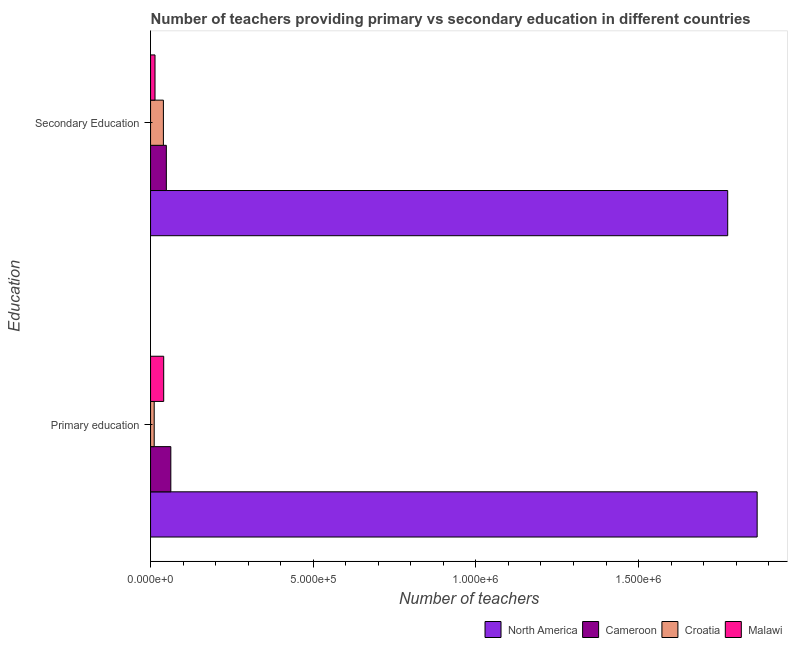How many different coloured bars are there?
Your answer should be compact. 4. How many groups of bars are there?
Keep it short and to the point. 2. How many bars are there on the 2nd tick from the bottom?
Offer a very short reply. 4. What is the label of the 2nd group of bars from the top?
Your response must be concise. Primary education. What is the number of primary teachers in Croatia?
Provide a succinct answer. 1.12e+04. Across all countries, what is the maximum number of primary teachers?
Offer a very short reply. 1.86e+06. Across all countries, what is the minimum number of secondary teachers?
Your response must be concise. 1.37e+04. In which country was the number of primary teachers maximum?
Give a very brief answer. North America. In which country was the number of secondary teachers minimum?
Your answer should be compact. Malawi. What is the total number of secondary teachers in the graph?
Your answer should be very brief. 1.88e+06. What is the difference between the number of primary teachers in North America and that in Malawi?
Offer a terse response. 1.82e+06. What is the difference between the number of primary teachers in Malawi and the number of secondary teachers in North America?
Give a very brief answer. -1.73e+06. What is the average number of primary teachers per country?
Your answer should be very brief. 4.95e+05. What is the difference between the number of secondary teachers and number of primary teachers in North America?
Your response must be concise. -9.06e+04. What is the ratio of the number of secondary teachers in North America to that in Cameroon?
Keep it short and to the point. 36.58. Is the number of primary teachers in North America less than that in Malawi?
Offer a terse response. No. What does the 1st bar from the top in Primary education represents?
Provide a succinct answer. Malawi. What does the 4th bar from the bottom in Secondary Education represents?
Offer a very short reply. Malawi. What is the difference between two consecutive major ticks on the X-axis?
Give a very brief answer. 5.00e+05. Are the values on the major ticks of X-axis written in scientific E-notation?
Your answer should be very brief. Yes. Does the graph contain any zero values?
Offer a very short reply. No. How are the legend labels stacked?
Your response must be concise. Horizontal. What is the title of the graph?
Make the answer very short. Number of teachers providing primary vs secondary education in different countries. What is the label or title of the X-axis?
Ensure brevity in your answer.  Number of teachers. What is the label or title of the Y-axis?
Offer a very short reply. Education. What is the Number of teachers of North America in Primary education?
Provide a succinct answer. 1.86e+06. What is the Number of teachers in Cameroon in Primary education?
Ensure brevity in your answer.  6.23e+04. What is the Number of teachers of Croatia in Primary education?
Make the answer very short. 1.12e+04. What is the Number of teachers of Malawi in Primary education?
Your response must be concise. 4.04e+04. What is the Number of teachers of North America in Secondary Education?
Keep it short and to the point. 1.77e+06. What is the Number of teachers in Cameroon in Secondary Education?
Your answer should be very brief. 4.85e+04. What is the Number of teachers of Croatia in Secondary Education?
Provide a succinct answer. 3.95e+04. What is the Number of teachers of Malawi in Secondary Education?
Ensure brevity in your answer.  1.37e+04. Across all Education, what is the maximum Number of teachers of North America?
Provide a short and direct response. 1.86e+06. Across all Education, what is the maximum Number of teachers in Cameroon?
Provide a short and direct response. 6.23e+04. Across all Education, what is the maximum Number of teachers of Croatia?
Give a very brief answer. 3.95e+04. Across all Education, what is the maximum Number of teachers in Malawi?
Keep it short and to the point. 4.04e+04. Across all Education, what is the minimum Number of teachers in North America?
Give a very brief answer. 1.77e+06. Across all Education, what is the minimum Number of teachers in Cameroon?
Provide a succinct answer. 4.85e+04. Across all Education, what is the minimum Number of teachers in Croatia?
Your answer should be compact. 1.12e+04. Across all Education, what is the minimum Number of teachers in Malawi?
Offer a terse response. 1.37e+04. What is the total Number of teachers of North America in the graph?
Make the answer very short. 3.64e+06. What is the total Number of teachers in Cameroon in the graph?
Your answer should be compact. 1.11e+05. What is the total Number of teachers in Croatia in the graph?
Offer a terse response. 5.07e+04. What is the total Number of teachers of Malawi in the graph?
Provide a short and direct response. 5.40e+04. What is the difference between the Number of teachers in North America in Primary education and that in Secondary Education?
Provide a succinct answer. 9.06e+04. What is the difference between the Number of teachers of Cameroon in Primary education and that in Secondary Education?
Make the answer very short. 1.38e+04. What is the difference between the Number of teachers of Croatia in Primary education and that in Secondary Education?
Your response must be concise. -2.83e+04. What is the difference between the Number of teachers in Malawi in Primary education and that in Secondary Education?
Your answer should be compact. 2.67e+04. What is the difference between the Number of teachers in North America in Primary education and the Number of teachers in Cameroon in Secondary Education?
Provide a short and direct response. 1.82e+06. What is the difference between the Number of teachers in North America in Primary education and the Number of teachers in Croatia in Secondary Education?
Keep it short and to the point. 1.83e+06. What is the difference between the Number of teachers of North America in Primary education and the Number of teachers of Malawi in Secondary Education?
Make the answer very short. 1.85e+06. What is the difference between the Number of teachers of Cameroon in Primary education and the Number of teachers of Croatia in Secondary Education?
Offer a very short reply. 2.28e+04. What is the difference between the Number of teachers of Cameroon in Primary education and the Number of teachers of Malawi in Secondary Education?
Your answer should be compact. 4.86e+04. What is the difference between the Number of teachers in Croatia in Primary education and the Number of teachers in Malawi in Secondary Education?
Your answer should be compact. -2461. What is the average Number of teachers in North America per Education?
Provide a short and direct response. 1.82e+06. What is the average Number of teachers in Cameroon per Education?
Offer a terse response. 5.54e+04. What is the average Number of teachers of Croatia per Education?
Make the answer very short. 2.53e+04. What is the average Number of teachers in Malawi per Education?
Keep it short and to the point. 2.70e+04. What is the difference between the Number of teachers in North America and Number of teachers in Cameroon in Primary education?
Offer a terse response. 1.80e+06. What is the difference between the Number of teachers in North America and Number of teachers in Croatia in Primary education?
Provide a succinct answer. 1.85e+06. What is the difference between the Number of teachers in North America and Number of teachers in Malawi in Primary education?
Your response must be concise. 1.82e+06. What is the difference between the Number of teachers of Cameroon and Number of teachers of Croatia in Primary education?
Keep it short and to the point. 5.11e+04. What is the difference between the Number of teachers in Cameroon and Number of teachers in Malawi in Primary education?
Keep it short and to the point. 2.19e+04. What is the difference between the Number of teachers in Croatia and Number of teachers in Malawi in Primary education?
Your answer should be very brief. -2.92e+04. What is the difference between the Number of teachers of North America and Number of teachers of Cameroon in Secondary Education?
Offer a very short reply. 1.73e+06. What is the difference between the Number of teachers of North America and Number of teachers of Croatia in Secondary Education?
Keep it short and to the point. 1.73e+06. What is the difference between the Number of teachers of North America and Number of teachers of Malawi in Secondary Education?
Your answer should be very brief. 1.76e+06. What is the difference between the Number of teachers in Cameroon and Number of teachers in Croatia in Secondary Education?
Offer a very short reply. 9025. What is the difference between the Number of teachers in Cameroon and Number of teachers in Malawi in Secondary Education?
Provide a short and direct response. 3.48e+04. What is the difference between the Number of teachers in Croatia and Number of teachers in Malawi in Secondary Education?
Offer a very short reply. 2.58e+04. What is the ratio of the Number of teachers of North America in Primary education to that in Secondary Education?
Your response must be concise. 1.05. What is the ratio of the Number of teachers in Cameroon in Primary education to that in Secondary Education?
Offer a very short reply. 1.28. What is the ratio of the Number of teachers of Croatia in Primary education to that in Secondary Education?
Your response must be concise. 0.28. What is the ratio of the Number of teachers of Malawi in Primary education to that in Secondary Education?
Your response must be concise. 2.96. What is the difference between the highest and the second highest Number of teachers of North America?
Offer a terse response. 9.06e+04. What is the difference between the highest and the second highest Number of teachers of Cameroon?
Make the answer very short. 1.38e+04. What is the difference between the highest and the second highest Number of teachers in Croatia?
Provide a short and direct response. 2.83e+04. What is the difference between the highest and the second highest Number of teachers of Malawi?
Provide a succinct answer. 2.67e+04. What is the difference between the highest and the lowest Number of teachers of North America?
Provide a succinct answer. 9.06e+04. What is the difference between the highest and the lowest Number of teachers in Cameroon?
Offer a very short reply. 1.38e+04. What is the difference between the highest and the lowest Number of teachers of Croatia?
Provide a succinct answer. 2.83e+04. What is the difference between the highest and the lowest Number of teachers of Malawi?
Make the answer very short. 2.67e+04. 